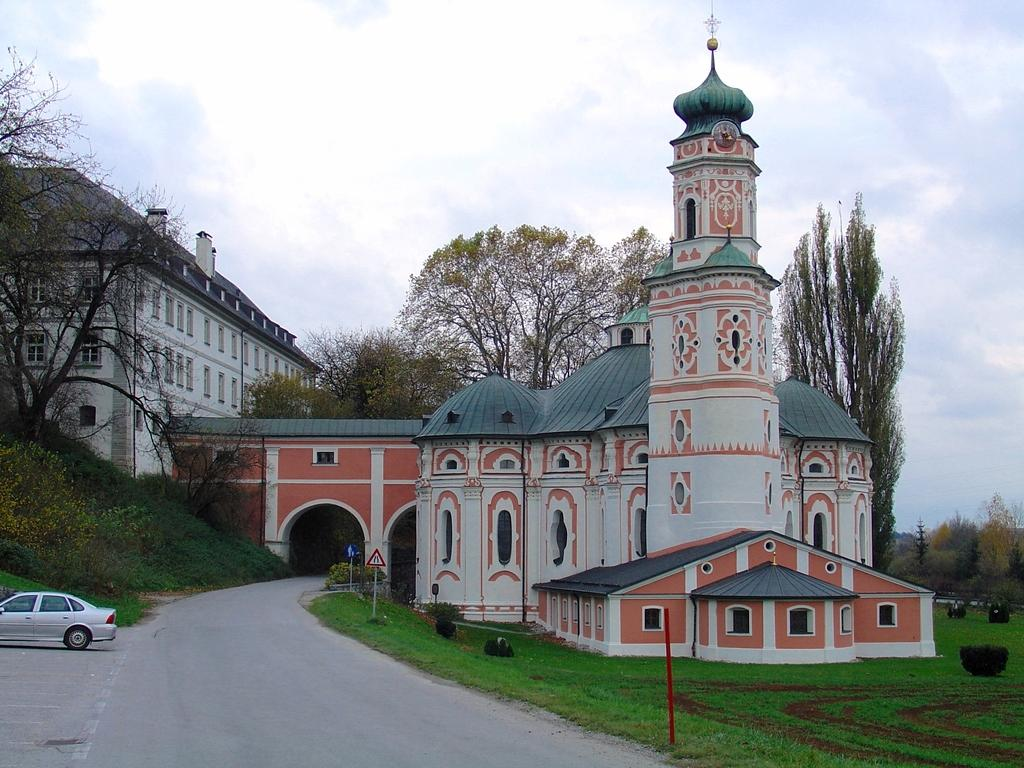What type of structures can be seen in the image? There are buildings in the image. What natural elements are present in the image? There are trees and plants in the image. What man-made objects can be seen in the image? There are sign boards and a car parked in the image. What is the condition of the ground in the image? There is grass on the ground in the image. What is the color and condition of the sky in the image? The sky is blue and cloudy in the image. What type of club is being discussed in the image? There is no discussion or club present in the image; it features buildings, trees, sign boards, plants, grass, a car, and a blue and cloudy sky. What is the title of the book being read by the person in the image? There is no person or book present in the image. 